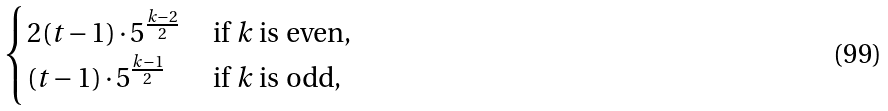<formula> <loc_0><loc_0><loc_500><loc_500>\begin{cases} 2 ( t - 1 ) \cdot 5 ^ { \frac { k - 2 } { 2 } } & \text { if $k$ is even,} \\ ( t - 1 ) \cdot 5 ^ { \frac { k - 1 } { 2 } } & \text { if $k$ is odd,} \end{cases}</formula> 